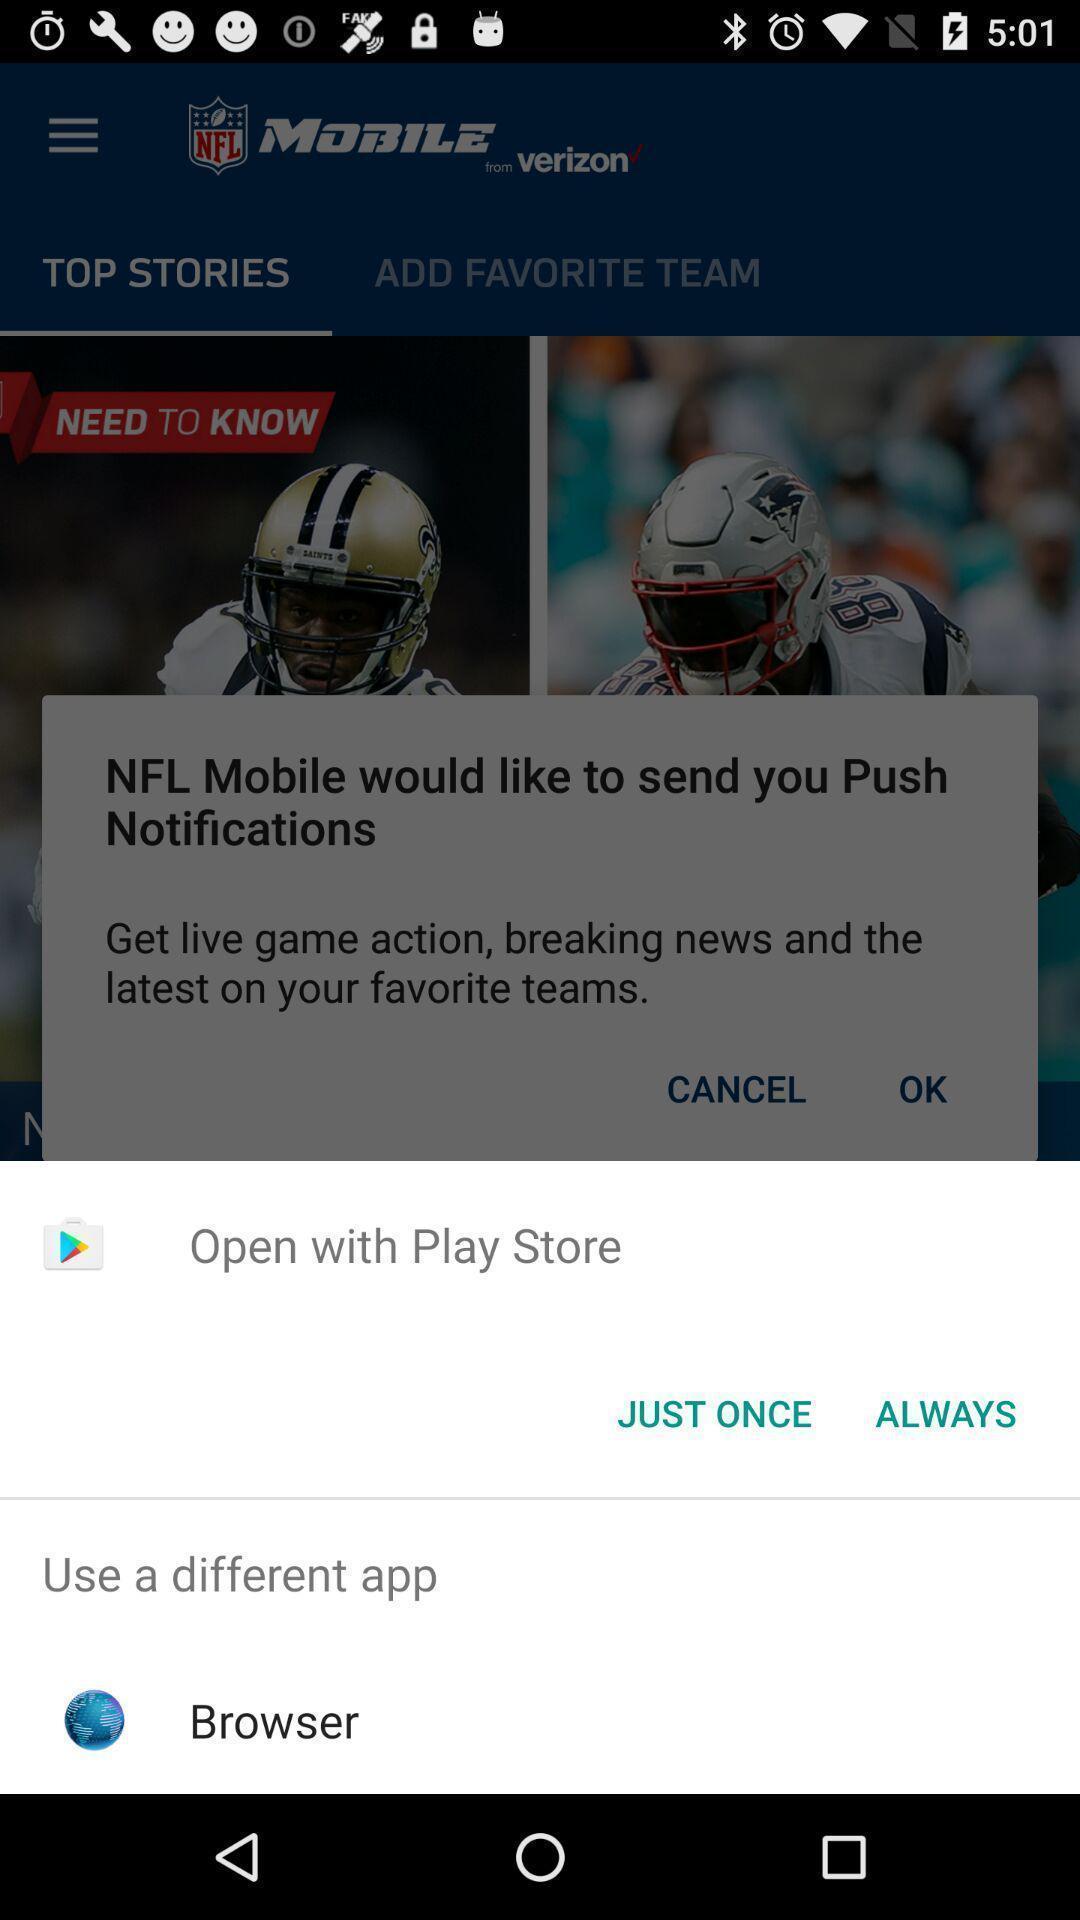Tell me what you see in this picture. Push up page displaying to open via other application. 